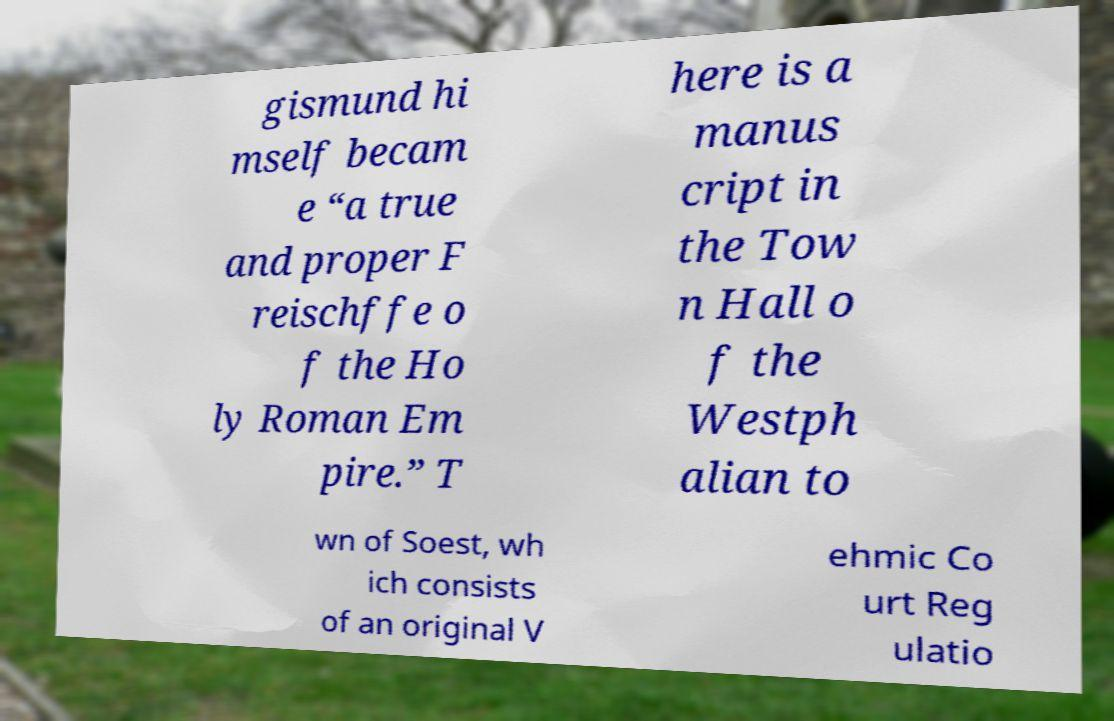I need the written content from this picture converted into text. Can you do that? gismund hi mself becam e “a true and proper F reischffe o f the Ho ly Roman Em pire.” T here is a manus cript in the Tow n Hall o f the Westph alian to wn of Soest, wh ich consists of an original V ehmic Co urt Reg ulatio 